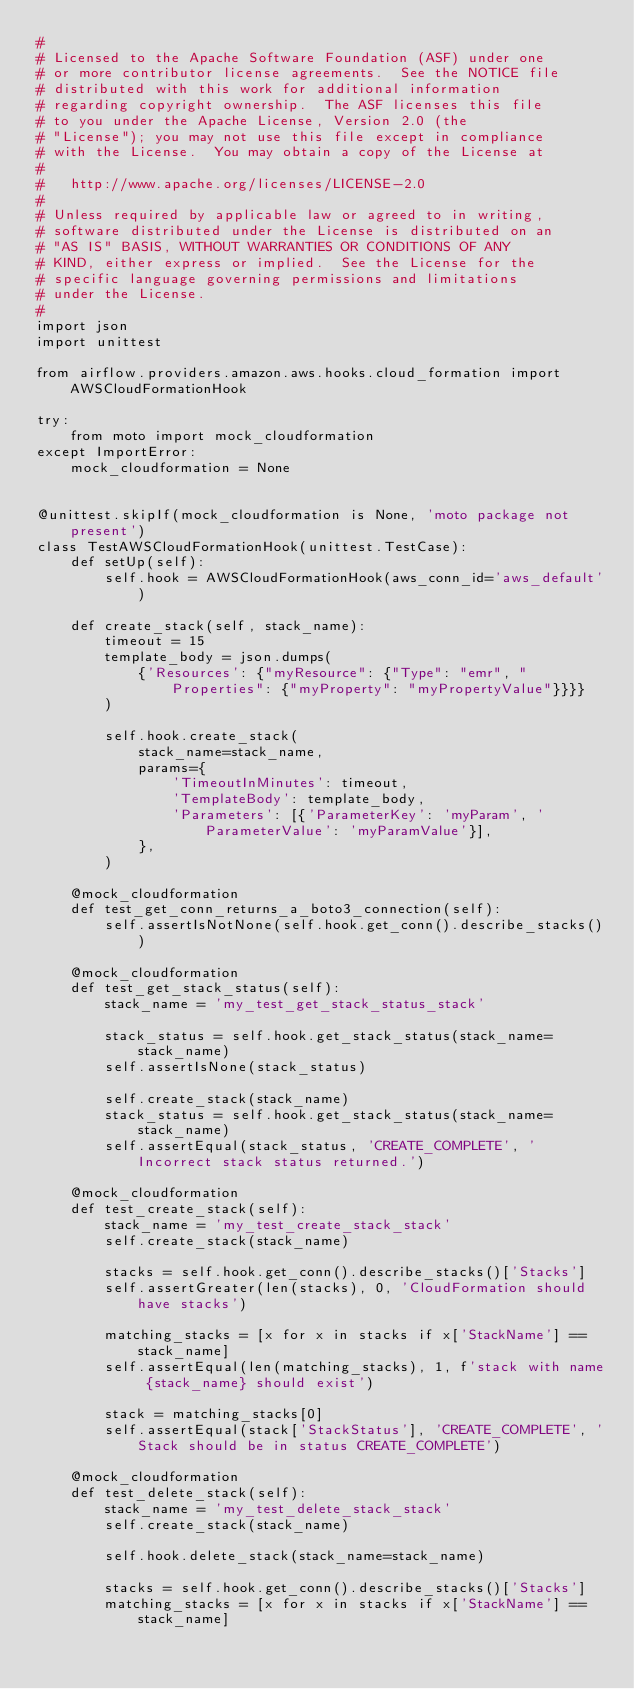Convert code to text. <code><loc_0><loc_0><loc_500><loc_500><_Python_>#
# Licensed to the Apache Software Foundation (ASF) under one
# or more contributor license agreements.  See the NOTICE file
# distributed with this work for additional information
# regarding copyright ownership.  The ASF licenses this file
# to you under the Apache License, Version 2.0 (the
# "License"); you may not use this file except in compliance
# with the License.  You may obtain a copy of the License at
#
#   http://www.apache.org/licenses/LICENSE-2.0
#
# Unless required by applicable law or agreed to in writing,
# software distributed under the License is distributed on an
# "AS IS" BASIS, WITHOUT WARRANTIES OR CONDITIONS OF ANY
# KIND, either express or implied.  See the License for the
# specific language governing permissions and limitations
# under the License.
#
import json
import unittest

from airflow.providers.amazon.aws.hooks.cloud_formation import AWSCloudFormationHook

try:
    from moto import mock_cloudformation
except ImportError:
    mock_cloudformation = None


@unittest.skipIf(mock_cloudformation is None, 'moto package not present')
class TestAWSCloudFormationHook(unittest.TestCase):
    def setUp(self):
        self.hook = AWSCloudFormationHook(aws_conn_id='aws_default')

    def create_stack(self, stack_name):
        timeout = 15
        template_body = json.dumps(
            {'Resources': {"myResource": {"Type": "emr", "Properties": {"myProperty": "myPropertyValue"}}}}
        )

        self.hook.create_stack(
            stack_name=stack_name,
            params={
                'TimeoutInMinutes': timeout,
                'TemplateBody': template_body,
                'Parameters': [{'ParameterKey': 'myParam', 'ParameterValue': 'myParamValue'}],
            },
        )

    @mock_cloudformation
    def test_get_conn_returns_a_boto3_connection(self):
        self.assertIsNotNone(self.hook.get_conn().describe_stacks())

    @mock_cloudformation
    def test_get_stack_status(self):
        stack_name = 'my_test_get_stack_status_stack'

        stack_status = self.hook.get_stack_status(stack_name=stack_name)
        self.assertIsNone(stack_status)

        self.create_stack(stack_name)
        stack_status = self.hook.get_stack_status(stack_name=stack_name)
        self.assertEqual(stack_status, 'CREATE_COMPLETE', 'Incorrect stack status returned.')

    @mock_cloudformation
    def test_create_stack(self):
        stack_name = 'my_test_create_stack_stack'
        self.create_stack(stack_name)

        stacks = self.hook.get_conn().describe_stacks()['Stacks']
        self.assertGreater(len(stacks), 0, 'CloudFormation should have stacks')

        matching_stacks = [x for x in stacks if x['StackName'] == stack_name]
        self.assertEqual(len(matching_stacks), 1, f'stack with name {stack_name} should exist')

        stack = matching_stacks[0]
        self.assertEqual(stack['StackStatus'], 'CREATE_COMPLETE', 'Stack should be in status CREATE_COMPLETE')

    @mock_cloudformation
    def test_delete_stack(self):
        stack_name = 'my_test_delete_stack_stack'
        self.create_stack(stack_name)

        self.hook.delete_stack(stack_name=stack_name)

        stacks = self.hook.get_conn().describe_stacks()['Stacks']
        matching_stacks = [x for x in stacks if x['StackName'] == stack_name]</code> 